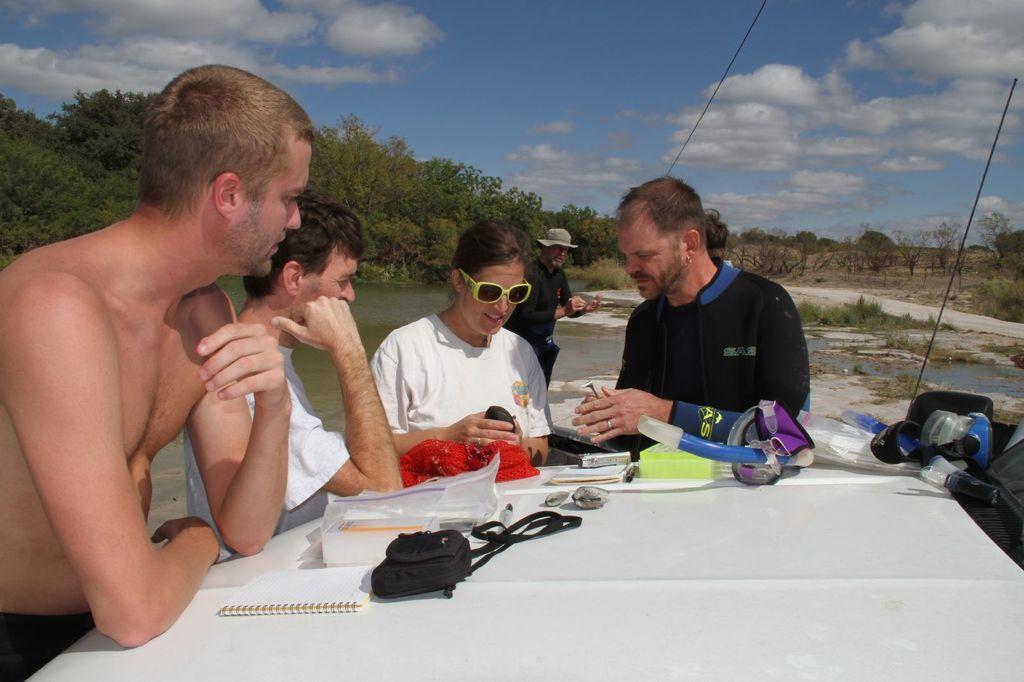Describe this image in one or two sentences. In this picture we can see a group of people and in front of them we can see a bag, books, plastic covers and some objects, water, trees and in the background we can see the sky with clouds. 